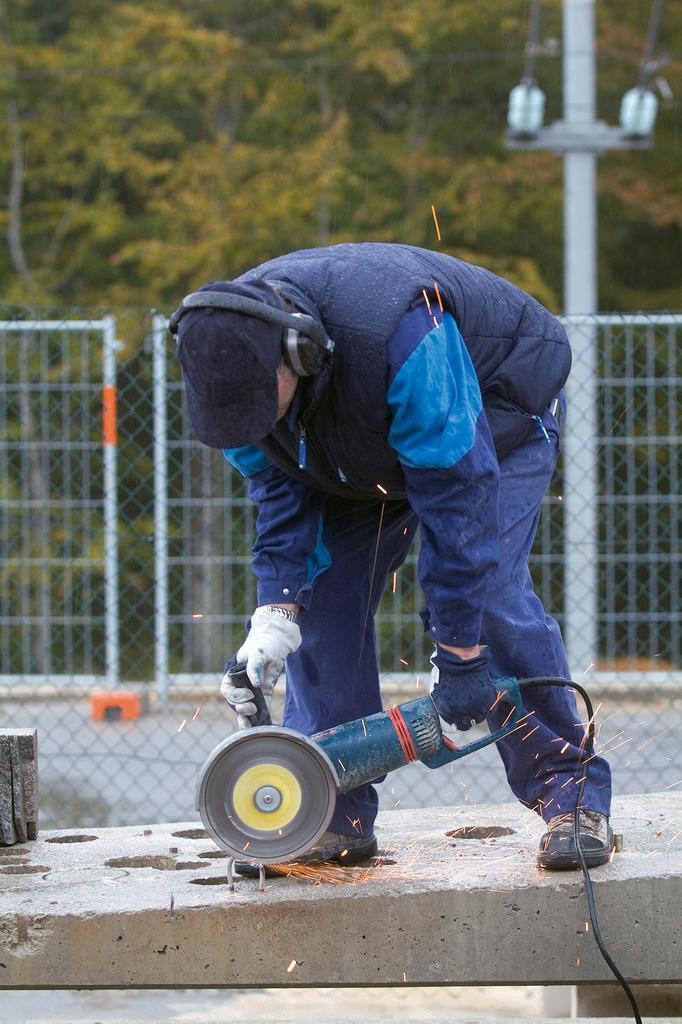Describe this image in one or two sentences. This image consists of a man wearing a blue dress and a blue jacket. He is also wearing headset and holding a cutting machine. He is cutting a metal part. At the bottom, there is a basement. In the background, there is a fencing along with trees and a pole. In the middle, there is a road. 